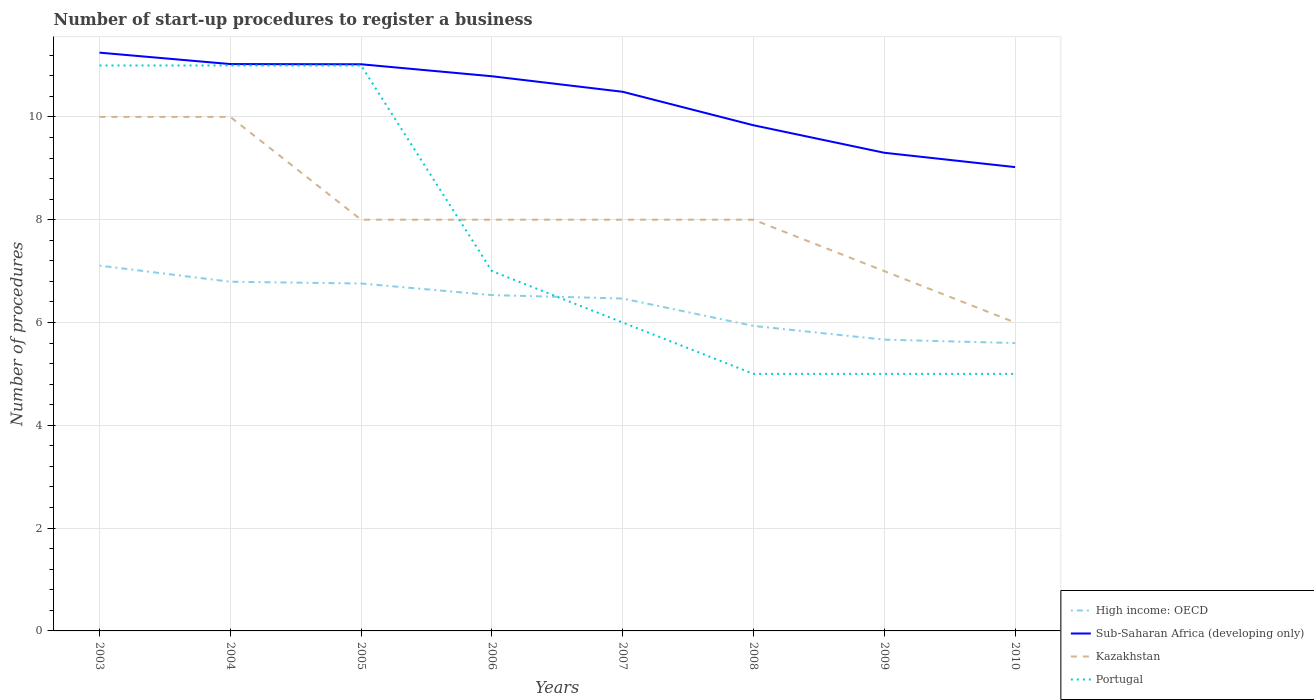Across all years, what is the maximum number of procedures required to register a business in Sub-Saharan Africa (developing only)?
Offer a very short reply. 9.02. In which year was the number of procedures required to register a business in Kazakhstan maximum?
Ensure brevity in your answer.  2010. What is the total number of procedures required to register a business in High income: OECD in the graph?
Your answer should be compact. 0.07. What is the difference between the highest and the lowest number of procedures required to register a business in Sub-Saharan Africa (developing only)?
Ensure brevity in your answer.  5. How many lines are there?
Give a very brief answer. 4. What is the difference between two consecutive major ticks on the Y-axis?
Ensure brevity in your answer.  2. Does the graph contain grids?
Offer a terse response. Yes. What is the title of the graph?
Provide a succinct answer. Number of start-up procedures to register a business. Does "Equatorial Guinea" appear as one of the legend labels in the graph?
Give a very brief answer. No. What is the label or title of the X-axis?
Offer a terse response. Years. What is the label or title of the Y-axis?
Your answer should be compact. Number of procedures. What is the Number of procedures in High income: OECD in 2003?
Give a very brief answer. 7.11. What is the Number of procedures of Sub-Saharan Africa (developing only) in 2003?
Your answer should be compact. 11.25. What is the Number of procedures in High income: OECD in 2004?
Offer a very short reply. 6.79. What is the Number of procedures in Sub-Saharan Africa (developing only) in 2004?
Offer a terse response. 11.03. What is the Number of procedures in High income: OECD in 2005?
Offer a terse response. 6.76. What is the Number of procedures of Sub-Saharan Africa (developing only) in 2005?
Your response must be concise. 11.02. What is the Number of procedures in Kazakhstan in 2005?
Give a very brief answer. 8. What is the Number of procedures of Portugal in 2005?
Offer a very short reply. 11. What is the Number of procedures of High income: OECD in 2006?
Ensure brevity in your answer.  6.53. What is the Number of procedures of Sub-Saharan Africa (developing only) in 2006?
Provide a succinct answer. 10.79. What is the Number of procedures in High income: OECD in 2007?
Your answer should be very brief. 6.47. What is the Number of procedures of Sub-Saharan Africa (developing only) in 2007?
Your answer should be very brief. 10.49. What is the Number of procedures of Kazakhstan in 2007?
Ensure brevity in your answer.  8. What is the Number of procedures of High income: OECD in 2008?
Offer a terse response. 5.93. What is the Number of procedures of Sub-Saharan Africa (developing only) in 2008?
Your answer should be very brief. 9.84. What is the Number of procedures in Kazakhstan in 2008?
Your answer should be very brief. 8. What is the Number of procedures of Portugal in 2008?
Offer a terse response. 5. What is the Number of procedures of High income: OECD in 2009?
Provide a succinct answer. 5.67. What is the Number of procedures of Sub-Saharan Africa (developing only) in 2009?
Offer a terse response. 9.3. What is the Number of procedures of Kazakhstan in 2009?
Offer a very short reply. 7. What is the Number of procedures of Sub-Saharan Africa (developing only) in 2010?
Make the answer very short. 9.02. What is the Number of procedures in Kazakhstan in 2010?
Offer a terse response. 6. Across all years, what is the maximum Number of procedures of High income: OECD?
Make the answer very short. 7.11. Across all years, what is the maximum Number of procedures of Sub-Saharan Africa (developing only)?
Offer a very short reply. 11.25. Across all years, what is the minimum Number of procedures in High income: OECD?
Your answer should be compact. 5.6. Across all years, what is the minimum Number of procedures of Sub-Saharan Africa (developing only)?
Offer a very short reply. 9.02. Across all years, what is the minimum Number of procedures of Portugal?
Your answer should be very brief. 5. What is the total Number of procedures of High income: OECD in the graph?
Provide a short and direct response. 50.86. What is the total Number of procedures in Sub-Saharan Africa (developing only) in the graph?
Your response must be concise. 82.74. What is the total Number of procedures of Portugal in the graph?
Keep it short and to the point. 61. What is the difference between the Number of procedures in High income: OECD in 2003 and that in 2004?
Offer a terse response. 0.31. What is the difference between the Number of procedures in Sub-Saharan Africa (developing only) in 2003 and that in 2004?
Your answer should be compact. 0.22. What is the difference between the Number of procedures in High income: OECD in 2003 and that in 2005?
Ensure brevity in your answer.  0.35. What is the difference between the Number of procedures of Sub-Saharan Africa (developing only) in 2003 and that in 2005?
Your answer should be compact. 0.23. What is the difference between the Number of procedures in High income: OECD in 2003 and that in 2006?
Provide a succinct answer. 0.57. What is the difference between the Number of procedures in Sub-Saharan Africa (developing only) in 2003 and that in 2006?
Make the answer very short. 0.46. What is the difference between the Number of procedures in Kazakhstan in 2003 and that in 2006?
Your answer should be compact. 2. What is the difference between the Number of procedures of High income: OECD in 2003 and that in 2007?
Your answer should be compact. 0.64. What is the difference between the Number of procedures in Sub-Saharan Africa (developing only) in 2003 and that in 2007?
Your answer should be very brief. 0.76. What is the difference between the Number of procedures in Portugal in 2003 and that in 2007?
Your answer should be compact. 5. What is the difference between the Number of procedures in High income: OECD in 2003 and that in 2008?
Your answer should be very brief. 1.17. What is the difference between the Number of procedures in Sub-Saharan Africa (developing only) in 2003 and that in 2008?
Your answer should be very brief. 1.41. What is the difference between the Number of procedures of Portugal in 2003 and that in 2008?
Your answer should be compact. 6. What is the difference between the Number of procedures in High income: OECD in 2003 and that in 2009?
Provide a short and direct response. 1.44. What is the difference between the Number of procedures in Sub-Saharan Africa (developing only) in 2003 and that in 2009?
Give a very brief answer. 1.95. What is the difference between the Number of procedures of Portugal in 2003 and that in 2009?
Keep it short and to the point. 6. What is the difference between the Number of procedures of High income: OECD in 2003 and that in 2010?
Give a very brief answer. 1.51. What is the difference between the Number of procedures of Sub-Saharan Africa (developing only) in 2003 and that in 2010?
Give a very brief answer. 2.23. What is the difference between the Number of procedures of Kazakhstan in 2003 and that in 2010?
Offer a very short reply. 4. What is the difference between the Number of procedures in High income: OECD in 2004 and that in 2005?
Provide a succinct answer. 0.03. What is the difference between the Number of procedures of Sub-Saharan Africa (developing only) in 2004 and that in 2005?
Provide a short and direct response. 0. What is the difference between the Number of procedures in Kazakhstan in 2004 and that in 2005?
Offer a terse response. 2. What is the difference between the Number of procedures of High income: OECD in 2004 and that in 2006?
Make the answer very short. 0.26. What is the difference between the Number of procedures in Sub-Saharan Africa (developing only) in 2004 and that in 2006?
Offer a very short reply. 0.24. What is the difference between the Number of procedures of Portugal in 2004 and that in 2006?
Ensure brevity in your answer.  4. What is the difference between the Number of procedures of High income: OECD in 2004 and that in 2007?
Provide a succinct answer. 0.33. What is the difference between the Number of procedures of Sub-Saharan Africa (developing only) in 2004 and that in 2007?
Your answer should be compact. 0.54. What is the difference between the Number of procedures of Kazakhstan in 2004 and that in 2007?
Your answer should be very brief. 2. What is the difference between the Number of procedures in Portugal in 2004 and that in 2007?
Ensure brevity in your answer.  5. What is the difference between the Number of procedures in High income: OECD in 2004 and that in 2008?
Give a very brief answer. 0.86. What is the difference between the Number of procedures of Sub-Saharan Africa (developing only) in 2004 and that in 2008?
Provide a succinct answer. 1.19. What is the difference between the Number of procedures of High income: OECD in 2004 and that in 2009?
Keep it short and to the point. 1.13. What is the difference between the Number of procedures in Sub-Saharan Africa (developing only) in 2004 and that in 2009?
Offer a very short reply. 1.73. What is the difference between the Number of procedures in Kazakhstan in 2004 and that in 2009?
Provide a short and direct response. 3. What is the difference between the Number of procedures in High income: OECD in 2004 and that in 2010?
Ensure brevity in your answer.  1.19. What is the difference between the Number of procedures in Sub-Saharan Africa (developing only) in 2004 and that in 2010?
Give a very brief answer. 2. What is the difference between the Number of procedures of Kazakhstan in 2004 and that in 2010?
Offer a terse response. 4. What is the difference between the Number of procedures of Portugal in 2004 and that in 2010?
Give a very brief answer. 6. What is the difference between the Number of procedures in High income: OECD in 2005 and that in 2006?
Your response must be concise. 0.23. What is the difference between the Number of procedures in Sub-Saharan Africa (developing only) in 2005 and that in 2006?
Make the answer very short. 0.23. What is the difference between the Number of procedures of Kazakhstan in 2005 and that in 2006?
Ensure brevity in your answer.  0. What is the difference between the Number of procedures in High income: OECD in 2005 and that in 2007?
Offer a terse response. 0.29. What is the difference between the Number of procedures in Sub-Saharan Africa (developing only) in 2005 and that in 2007?
Provide a succinct answer. 0.54. What is the difference between the Number of procedures of Kazakhstan in 2005 and that in 2007?
Your answer should be very brief. 0. What is the difference between the Number of procedures of High income: OECD in 2005 and that in 2008?
Provide a succinct answer. 0.83. What is the difference between the Number of procedures in Sub-Saharan Africa (developing only) in 2005 and that in 2008?
Make the answer very short. 1.19. What is the difference between the Number of procedures in Kazakhstan in 2005 and that in 2008?
Your answer should be compact. 0. What is the difference between the Number of procedures of Portugal in 2005 and that in 2008?
Keep it short and to the point. 6. What is the difference between the Number of procedures in High income: OECD in 2005 and that in 2009?
Offer a terse response. 1.09. What is the difference between the Number of procedures in Sub-Saharan Africa (developing only) in 2005 and that in 2009?
Offer a terse response. 1.72. What is the difference between the Number of procedures in Kazakhstan in 2005 and that in 2009?
Your answer should be compact. 1. What is the difference between the Number of procedures of High income: OECD in 2005 and that in 2010?
Ensure brevity in your answer.  1.16. What is the difference between the Number of procedures of Sub-Saharan Africa (developing only) in 2005 and that in 2010?
Your answer should be very brief. 2. What is the difference between the Number of procedures in Kazakhstan in 2005 and that in 2010?
Offer a terse response. 2. What is the difference between the Number of procedures in High income: OECD in 2006 and that in 2007?
Your answer should be very brief. 0.07. What is the difference between the Number of procedures of Sub-Saharan Africa (developing only) in 2006 and that in 2007?
Give a very brief answer. 0.3. What is the difference between the Number of procedures of Sub-Saharan Africa (developing only) in 2006 and that in 2008?
Offer a very short reply. 0.95. What is the difference between the Number of procedures of Kazakhstan in 2006 and that in 2008?
Offer a terse response. 0. What is the difference between the Number of procedures in High income: OECD in 2006 and that in 2009?
Offer a very short reply. 0.87. What is the difference between the Number of procedures of Sub-Saharan Africa (developing only) in 2006 and that in 2009?
Your response must be concise. 1.49. What is the difference between the Number of procedures of Portugal in 2006 and that in 2009?
Your response must be concise. 2. What is the difference between the Number of procedures in Sub-Saharan Africa (developing only) in 2006 and that in 2010?
Ensure brevity in your answer.  1.77. What is the difference between the Number of procedures of Portugal in 2006 and that in 2010?
Offer a terse response. 2. What is the difference between the Number of procedures in High income: OECD in 2007 and that in 2008?
Make the answer very short. 0.53. What is the difference between the Number of procedures in Sub-Saharan Africa (developing only) in 2007 and that in 2008?
Your answer should be very brief. 0.65. What is the difference between the Number of procedures of Kazakhstan in 2007 and that in 2008?
Provide a succinct answer. 0. What is the difference between the Number of procedures in Sub-Saharan Africa (developing only) in 2007 and that in 2009?
Your answer should be very brief. 1.19. What is the difference between the Number of procedures of Kazakhstan in 2007 and that in 2009?
Make the answer very short. 1. What is the difference between the Number of procedures of Portugal in 2007 and that in 2009?
Your response must be concise. 1. What is the difference between the Number of procedures in High income: OECD in 2007 and that in 2010?
Keep it short and to the point. 0.87. What is the difference between the Number of procedures of Sub-Saharan Africa (developing only) in 2007 and that in 2010?
Your answer should be compact. 1.47. What is the difference between the Number of procedures in Kazakhstan in 2007 and that in 2010?
Make the answer very short. 2. What is the difference between the Number of procedures of Portugal in 2007 and that in 2010?
Offer a terse response. 1. What is the difference between the Number of procedures of High income: OECD in 2008 and that in 2009?
Offer a very short reply. 0.27. What is the difference between the Number of procedures of Sub-Saharan Africa (developing only) in 2008 and that in 2009?
Make the answer very short. 0.53. What is the difference between the Number of procedures of High income: OECD in 2008 and that in 2010?
Provide a short and direct response. 0.33. What is the difference between the Number of procedures in Sub-Saharan Africa (developing only) in 2008 and that in 2010?
Provide a succinct answer. 0.81. What is the difference between the Number of procedures in High income: OECD in 2009 and that in 2010?
Offer a terse response. 0.07. What is the difference between the Number of procedures in Sub-Saharan Africa (developing only) in 2009 and that in 2010?
Your answer should be compact. 0.28. What is the difference between the Number of procedures of Kazakhstan in 2009 and that in 2010?
Offer a very short reply. 1. What is the difference between the Number of procedures of High income: OECD in 2003 and the Number of procedures of Sub-Saharan Africa (developing only) in 2004?
Ensure brevity in your answer.  -3.92. What is the difference between the Number of procedures of High income: OECD in 2003 and the Number of procedures of Kazakhstan in 2004?
Keep it short and to the point. -2.89. What is the difference between the Number of procedures in High income: OECD in 2003 and the Number of procedures in Portugal in 2004?
Keep it short and to the point. -3.89. What is the difference between the Number of procedures in Sub-Saharan Africa (developing only) in 2003 and the Number of procedures in Kazakhstan in 2004?
Make the answer very short. 1.25. What is the difference between the Number of procedures in Kazakhstan in 2003 and the Number of procedures in Portugal in 2004?
Provide a succinct answer. -1. What is the difference between the Number of procedures of High income: OECD in 2003 and the Number of procedures of Sub-Saharan Africa (developing only) in 2005?
Your response must be concise. -3.92. What is the difference between the Number of procedures in High income: OECD in 2003 and the Number of procedures in Kazakhstan in 2005?
Provide a succinct answer. -0.89. What is the difference between the Number of procedures of High income: OECD in 2003 and the Number of procedures of Portugal in 2005?
Offer a terse response. -3.89. What is the difference between the Number of procedures in Sub-Saharan Africa (developing only) in 2003 and the Number of procedures in Kazakhstan in 2005?
Your answer should be compact. 3.25. What is the difference between the Number of procedures in High income: OECD in 2003 and the Number of procedures in Sub-Saharan Africa (developing only) in 2006?
Offer a very short reply. -3.68. What is the difference between the Number of procedures in High income: OECD in 2003 and the Number of procedures in Kazakhstan in 2006?
Your answer should be very brief. -0.89. What is the difference between the Number of procedures in High income: OECD in 2003 and the Number of procedures in Portugal in 2006?
Offer a terse response. 0.11. What is the difference between the Number of procedures in Sub-Saharan Africa (developing only) in 2003 and the Number of procedures in Kazakhstan in 2006?
Provide a short and direct response. 3.25. What is the difference between the Number of procedures of Sub-Saharan Africa (developing only) in 2003 and the Number of procedures of Portugal in 2006?
Provide a short and direct response. 4.25. What is the difference between the Number of procedures in High income: OECD in 2003 and the Number of procedures in Sub-Saharan Africa (developing only) in 2007?
Provide a succinct answer. -3.38. What is the difference between the Number of procedures of High income: OECD in 2003 and the Number of procedures of Kazakhstan in 2007?
Your answer should be compact. -0.89. What is the difference between the Number of procedures in High income: OECD in 2003 and the Number of procedures in Portugal in 2007?
Ensure brevity in your answer.  1.11. What is the difference between the Number of procedures of Sub-Saharan Africa (developing only) in 2003 and the Number of procedures of Kazakhstan in 2007?
Your answer should be very brief. 3.25. What is the difference between the Number of procedures of Sub-Saharan Africa (developing only) in 2003 and the Number of procedures of Portugal in 2007?
Give a very brief answer. 5.25. What is the difference between the Number of procedures in High income: OECD in 2003 and the Number of procedures in Sub-Saharan Africa (developing only) in 2008?
Give a very brief answer. -2.73. What is the difference between the Number of procedures of High income: OECD in 2003 and the Number of procedures of Kazakhstan in 2008?
Your response must be concise. -0.89. What is the difference between the Number of procedures in High income: OECD in 2003 and the Number of procedures in Portugal in 2008?
Keep it short and to the point. 2.11. What is the difference between the Number of procedures in Sub-Saharan Africa (developing only) in 2003 and the Number of procedures in Kazakhstan in 2008?
Keep it short and to the point. 3.25. What is the difference between the Number of procedures of Sub-Saharan Africa (developing only) in 2003 and the Number of procedures of Portugal in 2008?
Give a very brief answer. 6.25. What is the difference between the Number of procedures of High income: OECD in 2003 and the Number of procedures of Sub-Saharan Africa (developing only) in 2009?
Offer a very short reply. -2.2. What is the difference between the Number of procedures of High income: OECD in 2003 and the Number of procedures of Kazakhstan in 2009?
Provide a short and direct response. 0.11. What is the difference between the Number of procedures of High income: OECD in 2003 and the Number of procedures of Portugal in 2009?
Provide a short and direct response. 2.11. What is the difference between the Number of procedures in Sub-Saharan Africa (developing only) in 2003 and the Number of procedures in Kazakhstan in 2009?
Ensure brevity in your answer.  4.25. What is the difference between the Number of procedures in Sub-Saharan Africa (developing only) in 2003 and the Number of procedures in Portugal in 2009?
Offer a terse response. 6.25. What is the difference between the Number of procedures of High income: OECD in 2003 and the Number of procedures of Sub-Saharan Africa (developing only) in 2010?
Your response must be concise. -1.92. What is the difference between the Number of procedures of High income: OECD in 2003 and the Number of procedures of Kazakhstan in 2010?
Your answer should be very brief. 1.11. What is the difference between the Number of procedures of High income: OECD in 2003 and the Number of procedures of Portugal in 2010?
Keep it short and to the point. 2.11. What is the difference between the Number of procedures in Sub-Saharan Africa (developing only) in 2003 and the Number of procedures in Kazakhstan in 2010?
Your response must be concise. 5.25. What is the difference between the Number of procedures in Sub-Saharan Africa (developing only) in 2003 and the Number of procedures in Portugal in 2010?
Your answer should be compact. 6.25. What is the difference between the Number of procedures of Kazakhstan in 2003 and the Number of procedures of Portugal in 2010?
Your answer should be compact. 5. What is the difference between the Number of procedures in High income: OECD in 2004 and the Number of procedures in Sub-Saharan Africa (developing only) in 2005?
Provide a succinct answer. -4.23. What is the difference between the Number of procedures in High income: OECD in 2004 and the Number of procedures in Kazakhstan in 2005?
Give a very brief answer. -1.21. What is the difference between the Number of procedures in High income: OECD in 2004 and the Number of procedures in Portugal in 2005?
Ensure brevity in your answer.  -4.21. What is the difference between the Number of procedures of Sub-Saharan Africa (developing only) in 2004 and the Number of procedures of Kazakhstan in 2005?
Offer a terse response. 3.03. What is the difference between the Number of procedures of Sub-Saharan Africa (developing only) in 2004 and the Number of procedures of Portugal in 2005?
Keep it short and to the point. 0.03. What is the difference between the Number of procedures of High income: OECD in 2004 and the Number of procedures of Sub-Saharan Africa (developing only) in 2006?
Give a very brief answer. -4. What is the difference between the Number of procedures of High income: OECD in 2004 and the Number of procedures of Kazakhstan in 2006?
Ensure brevity in your answer.  -1.21. What is the difference between the Number of procedures of High income: OECD in 2004 and the Number of procedures of Portugal in 2006?
Give a very brief answer. -0.21. What is the difference between the Number of procedures in Sub-Saharan Africa (developing only) in 2004 and the Number of procedures in Kazakhstan in 2006?
Your answer should be compact. 3.03. What is the difference between the Number of procedures in Sub-Saharan Africa (developing only) in 2004 and the Number of procedures in Portugal in 2006?
Give a very brief answer. 4.03. What is the difference between the Number of procedures in Kazakhstan in 2004 and the Number of procedures in Portugal in 2006?
Provide a short and direct response. 3. What is the difference between the Number of procedures in High income: OECD in 2004 and the Number of procedures in Sub-Saharan Africa (developing only) in 2007?
Your answer should be very brief. -3.7. What is the difference between the Number of procedures in High income: OECD in 2004 and the Number of procedures in Kazakhstan in 2007?
Provide a succinct answer. -1.21. What is the difference between the Number of procedures of High income: OECD in 2004 and the Number of procedures of Portugal in 2007?
Provide a short and direct response. 0.79. What is the difference between the Number of procedures of Sub-Saharan Africa (developing only) in 2004 and the Number of procedures of Kazakhstan in 2007?
Give a very brief answer. 3.03. What is the difference between the Number of procedures of Sub-Saharan Africa (developing only) in 2004 and the Number of procedures of Portugal in 2007?
Ensure brevity in your answer.  5.03. What is the difference between the Number of procedures of Kazakhstan in 2004 and the Number of procedures of Portugal in 2007?
Your answer should be very brief. 4. What is the difference between the Number of procedures of High income: OECD in 2004 and the Number of procedures of Sub-Saharan Africa (developing only) in 2008?
Ensure brevity in your answer.  -3.04. What is the difference between the Number of procedures in High income: OECD in 2004 and the Number of procedures in Kazakhstan in 2008?
Your answer should be very brief. -1.21. What is the difference between the Number of procedures of High income: OECD in 2004 and the Number of procedures of Portugal in 2008?
Give a very brief answer. 1.79. What is the difference between the Number of procedures of Sub-Saharan Africa (developing only) in 2004 and the Number of procedures of Kazakhstan in 2008?
Provide a short and direct response. 3.03. What is the difference between the Number of procedures in Sub-Saharan Africa (developing only) in 2004 and the Number of procedures in Portugal in 2008?
Offer a very short reply. 6.03. What is the difference between the Number of procedures in Kazakhstan in 2004 and the Number of procedures in Portugal in 2008?
Give a very brief answer. 5. What is the difference between the Number of procedures in High income: OECD in 2004 and the Number of procedures in Sub-Saharan Africa (developing only) in 2009?
Give a very brief answer. -2.51. What is the difference between the Number of procedures of High income: OECD in 2004 and the Number of procedures of Kazakhstan in 2009?
Provide a succinct answer. -0.21. What is the difference between the Number of procedures in High income: OECD in 2004 and the Number of procedures in Portugal in 2009?
Provide a succinct answer. 1.79. What is the difference between the Number of procedures in Sub-Saharan Africa (developing only) in 2004 and the Number of procedures in Kazakhstan in 2009?
Ensure brevity in your answer.  4.03. What is the difference between the Number of procedures of Sub-Saharan Africa (developing only) in 2004 and the Number of procedures of Portugal in 2009?
Give a very brief answer. 6.03. What is the difference between the Number of procedures of Kazakhstan in 2004 and the Number of procedures of Portugal in 2009?
Your answer should be very brief. 5. What is the difference between the Number of procedures of High income: OECD in 2004 and the Number of procedures of Sub-Saharan Africa (developing only) in 2010?
Offer a very short reply. -2.23. What is the difference between the Number of procedures in High income: OECD in 2004 and the Number of procedures in Kazakhstan in 2010?
Your answer should be very brief. 0.79. What is the difference between the Number of procedures in High income: OECD in 2004 and the Number of procedures in Portugal in 2010?
Keep it short and to the point. 1.79. What is the difference between the Number of procedures of Sub-Saharan Africa (developing only) in 2004 and the Number of procedures of Kazakhstan in 2010?
Offer a very short reply. 5.03. What is the difference between the Number of procedures in Sub-Saharan Africa (developing only) in 2004 and the Number of procedures in Portugal in 2010?
Provide a short and direct response. 6.03. What is the difference between the Number of procedures of High income: OECD in 2005 and the Number of procedures of Sub-Saharan Africa (developing only) in 2006?
Keep it short and to the point. -4.03. What is the difference between the Number of procedures in High income: OECD in 2005 and the Number of procedures in Kazakhstan in 2006?
Offer a terse response. -1.24. What is the difference between the Number of procedures in High income: OECD in 2005 and the Number of procedures in Portugal in 2006?
Provide a succinct answer. -0.24. What is the difference between the Number of procedures in Sub-Saharan Africa (developing only) in 2005 and the Number of procedures in Kazakhstan in 2006?
Provide a short and direct response. 3.02. What is the difference between the Number of procedures in Sub-Saharan Africa (developing only) in 2005 and the Number of procedures in Portugal in 2006?
Keep it short and to the point. 4.02. What is the difference between the Number of procedures of High income: OECD in 2005 and the Number of procedures of Sub-Saharan Africa (developing only) in 2007?
Offer a terse response. -3.73. What is the difference between the Number of procedures in High income: OECD in 2005 and the Number of procedures in Kazakhstan in 2007?
Offer a very short reply. -1.24. What is the difference between the Number of procedures of High income: OECD in 2005 and the Number of procedures of Portugal in 2007?
Keep it short and to the point. 0.76. What is the difference between the Number of procedures of Sub-Saharan Africa (developing only) in 2005 and the Number of procedures of Kazakhstan in 2007?
Offer a very short reply. 3.02. What is the difference between the Number of procedures of Sub-Saharan Africa (developing only) in 2005 and the Number of procedures of Portugal in 2007?
Ensure brevity in your answer.  5.02. What is the difference between the Number of procedures in High income: OECD in 2005 and the Number of procedures in Sub-Saharan Africa (developing only) in 2008?
Your answer should be compact. -3.08. What is the difference between the Number of procedures in High income: OECD in 2005 and the Number of procedures in Kazakhstan in 2008?
Provide a succinct answer. -1.24. What is the difference between the Number of procedures of High income: OECD in 2005 and the Number of procedures of Portugal in 2008?
Offer a very short reply. 1.76. What is the difference between the Number of procedures in Sub-Saharan Africa (developing only) in 2005 and the Number of procedures in Kazakhstan in 2008?
Offer a terse response. 3.02. What is the difference between the Number of procedures in Sub-Saharan Africa (developing only) in 2005 and the Number of procedures in Portugal in 2008?
Make the answer very short. 6.02. What is the difference between the Number of procedures in Kazakhstan in 2005 and the Number of procedures in Portugal in 2008?
Provide a short and direct response. 3. What is the difference between the Number of procedures in High income: OECD in 2005 and the Number of procedures in Sub-Saharan Africa (developing only) in 2009?
Keep it short and to the point. -2.54. What is the difference between the Number of procedures of High income: OECD in 2005 and the Number of procedures of Kazakhstan in 2009?
Offer a terse response. -0.24. What is the difference between the Number of procedures of High income: OECD in 2005 and the Number of procedures of Portugal in 2009?
Your answer should be very brief. 1.76. What is the difference between the Number of procedures in Sub-Saharan Africa (developing only) in 2005 and the Number of procedures in Kazakhstan in 2009?
Offer a terse response. 4.02. What is the difference between the Number of procedures of Sub-Saharan Africa (developing only) in 2005 and the Number of procedures of Portugal in 2009?
Your response must be concise. 6.02. What is the difference between the Number of procedures in High income: OECD in 2005 and the Number of procedures in Sub-Saharan Africa (developing only) in 2010?
Your response must be concise. -2.26. What is the difference between the Number of procedures in High income: OECD in 2005 and the Number of procedures in Kazakhstan in 2010?
Keep it short and to the point. 0.76. What is the difference between the Number of procedures of High income: OECD in 2005 and the Number of procedures of Portugal in 2010?
Your answer should be compact. 1.76. What is the difference between the Number of procedures of Sub-Saharan Africa (developing only) in 2005 and the Number of procedures of Kazakhstan in 2010?
Offer a terse response. 5.02. What is the difference between the Number of procedures in Sub-Saharan Africa (developing only) in 2005 and the Number of procedures in Portugal in 2010?
Give a very brief answer. 6.02. What is the difference between the Number of procedures of High income: OECD in 2006 and the Number of procedures of Sub-Saharan Africa (developing only) in 2007?
Your answer should be compact. -3.96. What is the difference between the Number of procedures in High income: OECD in 2006 and the Number of procedures in Kazakhstan in 2007?
Your response must be concise. -1.47. What is the difference between the Number of procedures of High income: OECD in 2006 and the Number of procedures of Portugal in 2007?
Provide a short and direct response. 0.53. What is the difference between the Number of procedures of Sub-Saharan Africa (developing only) in 2006 and the Number of procedures of Kazakhstan in 2007?
Your answer should be very brief. 2.79. What is the difference between the Number of procedures in Sub-Saharan Africa (developing only) in 2006 and the Number of procedures in Portugal in 2007?
Give a very brief answer. 4.79. What is the difference between the Number of procedures in High income: OECD in 2006 and the Number of procedures in Sub-Saharan Africa (developing only) in 2008?
Offer a terse response. -3.3. What is the difference between the Number of procedures of High income: OECD in 2006 and the Number of procedures of Kazakhstan in 2008?
Your answer should be compact. -1.47. What is the difference between the Number of procedures in High income: OECD in 2006 and the Number of procedures in Portugal in 2008?
Offer a terse response. 1.53. What is the difference between the Number of procedures in Sub-Saharan Africa (developing only) in 2006 and the Number of procedures in Kazakhstan in 2008?
Keep it short and to the point. 2.79. What is the difference between the Number of procedures of Sub-Saharan Africa (developing only) in 2006 and the Number of procedures of Portugal in 2008?
Your response must be concise. 5.79. What is the difference between the Number of procedures in High income: OECD in 2006 and the Number of procedures in Sub-Saharan Africa (developing only) in 2009?
Offer a terse response. -2.77. What is the difference between the Number of procedures of High income: OECD in 2006 and the Number of procedures of Kazakhstan in 2009?
Your answer should be very brief. -0.47. What is the difference between the Number of procedures of High income: OECD in 2006 and the Number of procedures of Portugal in 2009?
Your answer should be compact. 1.53. What is the difference between the Number of procedures of Sub-Saharan Africa (developing only) in 2006 and the Number of procedures of Kazakhstan in 2009?
Provide a short and direct response. 3.79. What is the difference between the Number of procedures in Sub-Saharan Africa (developing only) in 2006 and the Number of procedures in Portugal in 2009?
Give a very brief answer. 5.79. What is the difference between the Number of procedures in Kazakhstan in 2006 and the Number of procedures in Portugal in 2009?
Offer a very short reply. 3. What is the difference between the Number of procedures of High income: OECD in 2006 and the Number of procedures of Sub-Saharan Africa (developing only) in 2010?
Keep it short and to the point. -2.49. What is the difference between the Number of procedures of High income: OECD in 2006 and the Number of procedures of Kazakhstan in 2010?
Your response must be concise. 0.53. What is the difference between the Number of procedures of High income: OECD in 2006 and the Number of procedures of Portugal in 2010?
Your response must be concise. 1.53. What is the difference between the Number of procedures of Sub-Saharan Africa (developing only) in 2006 and the Number of procedures of Kazakhstan in 2010?
Your answer should be very brief. 4.79. What is the difference between the Number of procedures in Sub-Saharan Africa (developing only) in 2006 and the Number of procedures in Portugal in 2010?
Offer a terse response. 5.79. What is the difference between the Number of procedures in High income: OECD in 2007 and the Number of procedures in Sub-Saharan Africa (developing only) in 2008?
Ensure brevity in your answer.  -3.37. What is the difference between the Number of procedures in High income: OECD in 2007 and the Number of procedures in Kazakhstan in 2008?
Make the answer very short. -1.53. What is the difference between the Number of procedures of High income: OECD in 2007 and the Number of procedures of Portugal in 2008?
Provide a short and direct response. 1.47. What is the difference between the Number of procedures of Sub-Saharan Africa (developing only) in 2007 and the Number of procedures of Kazakhstan in 2008?
Make the answer very short. 2.49. What is the difference between the Number of procedures of Sub-Saharan Africa (developing only) in 2007 and the Number of procedures of Portugal in 2008?
Offer a terse response. 5.49. What is the difference between the Number of procedures in Kazakhstan in 2007 and the Number of procedures in Portugal in 2008?
Your answer should be compact. 3. What is the difference between the Number of procedures in High income: OECD in 2007 and the Number of procedures in Sub-Saharan Africa (developing only) in 2009?
Offer a terse response. -2.84. What is the difference between the Number of procedures of High income: OECD in 2007 and the Number of procedures of Kazakhstan in 2009?
Your answer should be compact. -0.53. What is the difference between the Number of procedures in High income: OECD in 2007 and the Number of procedures in Portugal in 2009?
Keep it short and to the point. 1.47. What is the difference between the Number of procedures in Sub-Saharan Africa (developing only) in 2007 and the Number of procedures in Kazakhstan in 2009?
Provide a succinct answer. 3.49. What is the difference between the Number of procedures in Sub-Saharan Africa (developing only) in 2007 and the Number of procedures in Portugal in 2009?
Your answer should be very brief. 5.49. What is the difference between the Number of procedures of Kazakhstan in 2007 and the Number of procedures of Portugal in 2009?
Offer a terse response. 3. What is the difference between the Number of procedures in High income: OECD in 2007 and the Number of procedures in Sub-Saharan Africa (developing only) in 2010?
Provide a succinct answer. -2.56. What is the difference between the Number of procedures in High income: OECD in 2007 and the Number of procedures in Kazakhstan in 2010?
Provide a succinct answer. 0.47. What is the difference between the Number of procedures in High income: OECD in 2007 and the Number of procedures in Portugal in 2010?
Make the answer very short. 1.47. What is the difference between the Number of procedures in Sub-Saharan Africa (developing only) in 2007 and the Number of procedures in Kazakhstan in 2010?
Make the answer very short. 4.49. What is the difference between the Number of procedures in Sub-Saharan Africa (developing only) in 2007 and the Number of procedures in Portugal in 2010?
Provide a succinct answer. 5.49. What is the difference between the Number of procedures of Kazakhstan in 2007 and the Number of procedures of Portugal in 2010?
Make the answer very short. 3. What is the difference between the Number of procedures of High income: OECD in 2008 and the Number of procedures of Sub-Saharan Africa (developing only) in 2009?
Keep it short and to the point. -3.37. What is the difference between the Number of procedures in High income: OECD in 2008 and the Number of procedures in Kazakhstan in 2009?
Your answer should be compact. -1.07. What is the difference between the Number of procedures in Sub-Saharan Africa (developing only) in 2008 and the Number of procedures in Kazakhstan in 2009?
Offer a terse response. 2.84. What is the difference between the Number of procedures of Sub-Saharan Africa (developing only) in 2008 and the Number of procedures of Portugal in 2009?
Offer a terse response. 4.84. What is the difference between the Number of procedures in Kazakhstan in 2008 and the Number of procedures in Portugal in 2009?
Offer a very short reply. 3. What is the difference between the Number of procedures of High income: OECD in 2008 and the Number of procedures of Sub-Saharan Africa (developing only) in 2010?
Offer a very short reply. -3.09. What is the difference between the Number of procedures of High income: OECD in 2008 and the Number of procedures of Kazakhstan in 2010?
Offer a very short reply. -0.07. What is the difference between the Number of procedures in Sub-Saharan Africa (developing only) in 2008 and the Number of procedures in Kazakhstan in 2010?
Provide a short and direct response. 3.84. What is the difference between the Number of procedures of Sub-Saharan Africa (developing only) in 2008 and the Number of procedures of Portugal in 2010?
Your answer should be compact. 4.84. What is the difference between the Number of procedures of Kazakhstan in 2008 and the Number of procedures of Portugal in 2010?
Keep it short and to the point. 3. What is the difference between the Number of procedures in High income: OECD in 2009 and the Number of procedures in Sub-Saharan Africa (developing only) in 2010?
Your answer should be compact. -3.36. What is the difference between the Number of procedures of High income: OECD in 2009 and the Number of procedures of Kazakhstan in 2010?
Give a very brief answer. -0.33. What is the difference between the Number of procedures of Sub-Saharan Africa (developing only) in 2009 and the Number of procedures of Kazakhstan in 2010?
Your answer should be compact. 3.3. What is the difference between the Number of procedures of Sub-Saharan Africa (developing only) in 2009 and the Number of procedures of Portugal in 2010?
Offer a terse response. 4.3. What is the difference between the Number of procedures of Kazakhstan in 2009 and the Number of procedures of Portugal in 2010?
Provide a succinct answer. 2. What is the average Number of procedures in High income: OECD per year?
Ensure brevity in your answer.  6.36. What is the average Number of procedures in Sub-Saharan Africa (developing only) per year?
Ensure brevity in your answer.  10.34. What is the average Number of procedures of Kazakhstan per year?
Your answer should be compact. 8.12. What is the average Number of procedures in Portugal per year?
Keep it short and to the point. 7.62. In the year 2003, what is the difference between the Number of procedures in High income: OECD and Number of procedures in Sub-Saharan Africa (developing only)?
Your answer should be very brief. -4.14. In the year 2003, what is the difference between the Number of procedures of High income: OECD and Number of procedures of Kazakhstan?
Your answer should be very brief. -2.89. In the year 2003, what is the difference between the Number of procedures of High income: OECD and Number of procedures of Portugal?
Your answer should be very brief. -3.89. In the year 2003, what is the difference between the Number of procedures of Sub-Saharan Africa (developing only) and Number of procedures of Portugal?
Provide a short and direct response. 0.25. In the year 2004, what is the difference between the Number of procedures in High income: OECD and Number of procedures in Sub-Saharan Africa (developing only)?
Provide a succinct answer. -4.23. In the year 2004, what is the difference between the Number of procedures of High income: OECD and Number of procedures of Kazakhstan?
Offer a very short reply. -3.21. In the year 2004, what is the difference between the Number of procedures in High income: OECD and Number of procedures in Portugal?
Offer a very short reply. -4.21. In the year 2004, what is the difference between the Number of procedures in Sub-Saharan Africa (developing only) and Number of procedures in Kazakhstan?
Provide a short and direct response. 1.03. In the year 2004, what is the difference between the Number of procedures of Sub-Saharan Africa (developing only) and Number of procedures of Portugal?
Provide a succinct answer. 0.03. In the year 2005, what is the difference between the Number of procedures of High income: OECD and Number of procedures of Sub-Saharan Africa (developing only)?
Provide a succinct answer. -4.27. In the year 2005, what is the difference between the Number of procedures in High income: OECD and Number of procedures in Kazakhstan?
Offer a very short reply. -1.24. In the year 2005, what is the difference between the Number of procedures in High income: OECD and Number of procedures in Portugal?
Ensure brevity in your answer.  -4.24. In the year 2005, what is the difference between the Number of procedures in Sub-Saharan Africa (developing only) and Number of procedures in Kazakhstan?
Provide a short and direct response. 3.02. In the year 2005, what is the difference between the Number of procedures in Sub-Saharan Africa (developing only) and Number of procedures in Portugal?
Provide a short and direct response. 0.02. In the year 2005, what is the difference between the Number of procedures in Kazakhstan and Number of procedures in Portugal?
Provide a short and direct response. -3. In the year 2006, what is the difference between the Number of procedures in High income: OECD and Number of procedures in Sub-Saharan Africa (developing only)?
Offer a terse response. -4.26. In the year 2006, what is the difference between the Number of procedures of High income: OECD and Number of procedures of Kazakhstan?
Offer a terse response. -1.47. In the year 2006, what is the difference between the Number of procedures of High income: OECD and Number of procedures of Portugal?
Give a very brief answer. -0.47. In the year 2006, what is the difference between the Number of procedures of Sub-Saharan Africa (developing only) and Number of procedures of Kazakhstan?
Your response must be concise. 2.79. In the year 2006, what is the difference between the Number of procedures in Sub-Saharan Africa (developing only) and Number of procedures in Portugal?
Provide a succinct answer. 3.79. In the year 2007, what is the difference between the Number of procedures of High income: OECD and Number of procedures of Sub-Saharan Africa (developing only)?
Keep it short and to the point. -4.02. In the year 2007, what is the difference between the Number of procedures in High income: OECD and Number of procedures in Kazakhstan?
Ensure brevity in your answer.  -1.53. In the year 2007, what is the difference between the Number of procedures of High income: OECD and Number of procedures of Portugal?
Keep it short and to the point. 0.47. In the year 2007, what is the difference between the Number of procedures in Sub-Saharan Africa (developing only) and Number of procedures in Kazakhstan?
Provide a short and direct response. 2.49. In the year 2007, what is the difference between the Number of procedures in Sub-Saharan Africa (developing only) and Number of procedures in Portugal?
Your answer should be compact. 4.49. In the year 2008, what is the difference between the Number of procedures in High income: OECD and Number of procedures in Sub-Saharan Africa (developing only)?
Provide a short and direct response. -3.9. In the year 2008, what is the difference between the Number of procedures of High income: OECD and Number of procedures of Kazakhstan?
Provide a short and direct response. -2.07. In the year 2008, what is the difference between the Number of procedures of Sub-Saharan Africa (developing only) and Number of procedures of Kazakhstan?
Your answer should be compact. 1.84. In the year 2008, what is the difference between the Number of procedures of Sub-Saharan Africa (developing only) and Number of procedures of Portugal?
Ensure brevity in your answer.  4.84. In the year 2008, what is the difference between the Number of procedures of Kazakhstan and Number of procedures of Portugal?
Offer a very short reply. 3. In the year 2009, what is the difference between the Number of procedures of High income: OECD and Number of procedures of Sub-Saharan Africa (developing only)?
Provide a short and direct response. -3.64. In the year 2009, what is the difference between the Number of procedures of High income: OECD and Number of procedures of Kazakhstan?
Your answer should be compact. -1.33. In the year 2009, what is the difference between the Number of procedures in Sub-Saharan Africa (developing only) and Number of procedures in Kazakhstan?
Make the answer very short. 2.3. In the year 2009, what is the difference between the Number of procedures of Sub-Saharan Africa (developing only) and Number of procedures of Portugal?
Keep it short and to the point. 4.3. In the year 2010, what is the difference between the Number of procedures of High income: OECD and Number of procedures of Sub-Saharan Africa (developing only)?
Ensure brevity in your answer.  -3.42. In the year 2010, what is the difference between the Number of procedures in High income: OECD and Number of procedures in Kazakhstan?
Keep it short and to the point. -0.4. In the year 2010, what is the difference between the Number of procedures in Sub-Saharan Africa (developing only) and Number of procedures in Kazakhstan?
Provide a succinct answer. 3.02. In the year 2010, what is the difference between the Number of procedures of Sub-Saharan Africa (developing only) and Number of procedures of Portugal?
Keep it short and to the point. 4.02. What is the ratio of the Number of procedures in High income: OECD in 2003 to that in 2004?
Your answer should be compact. 1.05. What is the ratio of the Number of procedures of Sub-Saharan Africa (developing only) in 2003 to that in 2004?
Your response must be concise. 1.02. What is the ratio of the Number of procedures in Kazakhstan in 2003 to that in 2004?
Provide a short and direct response. 1. What is the ratio of the Number of procedures of High income: OECD in 2003 to that in 2005?
Provide a succinct answer. 1.05. What is the ratio of the Number of procedures of Sub-Saharan Africa (developing only) in 2003 to that in 2005?
Provide a succinct answer. 1.02. What is the ratio of the Number of procedures of Portugal in 2003 to that in 2005?
Keep it short and to the point. 1. What is the ratio of the Number of procedures of High income: OECD in 2003 to that in 2006?
Your response must be concise. 1.09. What is the ratio of the Number of procedures of Sub-Saharan Africa (developing only) in 2003 to that in 2006?
Offer a terse response. 1.04. What is the ratio of the Number of procedures in Portugal in 2003 to that in 2006?
Offer a very short reply. 1.57. What is the ratio of the Number of procedures in High income: OECD in 2003 to that in 2007?
Offer a terse response. 1.1. What is the ratio of the Number of procedures of Sub-Saharan Africa (developing only) in 2003 to that in 2007?
Provide a short and direct response. 1.07. What is the ratio of the Number of procedures of Portugal in 2003 to that in 2007?
Provide a short and direct response. 1.83. What is the ratio of the Number of procedures of High income: OECD in 2003 to that in 2008?
Keep it short and to the point. 1.2. What is the ratio of the Number of procedures in Sub-Saharan Africa (developing only) in 2003 to that in 2008?
Provide a succinct answer. 1.14. What is the ratio of the Number of procedures of Kazakhstan in 2003 to that in 2008?
Provide a succinct answer. 1.25. What is the ratio of the Number of procedures of Portugal in 2003 to that in 2008?
Keep it short and to the point. 2.2. What is the ratio of the Number of procedures in High income: OECD in 2003 to that in 2009?
Keep it short and to the point. 1.25. What is the ratio of the Number of procedures in Sub-Saharan Africa (developing only) in 2003 to that in 2009?
Your answer should be very brief. 1.21. What is the ratio of the Number of procedures of Kazakhstan in 2003 to that in 2009?
Make the answer very short. 1.43. What is the ratio of the Number of procedures of High income: OECD in 2003 to that in 2010?
Your response must be concise. 1.27. What is the ratio of the Number of procedures of Sub-Saharan Africa (developing only) in 2003 to that in 2010?
Give a very brief answer. 1.25. What is the ratio of the Number of procedures of Portugal in 2003 to that in 2010?
Ensure brevity in your answer.  2.2. What is the ratio of the Number of procedures of Sub-Saharan Africa (developing only) in 2004 to that in 2005?
Keep it short and to the point. 1. What is the ratio of the Number of procedures of Kazakhstan in 2004 to that in 2005?
Your response must be concise. 1.25. What is the ratio of the Number of procedures in Portugal in 2004 to that in 2005?
Provide a short and direct response. 1. What is the ratio of the Number of procedures of High income: OECD in 2004 to that in 2006?
Your answer should be compact. 1.04. What is the ratio of the Number of procedures in Sub-Saharan Africa (developing only) in 2004 to that in 2006?
Your response must be concise. 1.02. What is the ratio of the Number of procedures in Portugal in 2004 to that in 2006?
Offer a very short reply. 1.57. What is the ratio of the Number of procedures in High income: OECD in 2004 to that in 2007?
Your answer should be very brief. 1.05. What is the ratio of the Number of procedures of Sub-Saharan Africa (developing only) in 2004 to that in 2007?
Give a very brief answer. 1.05. What is the ratio of the Number of procedures in Kazakhstan in 2004 to that in 2007?
Offer a very short reply. 1.25. What is the ratio of the Number of procedures of Portugal in 2004 to that in 2007?
Offer a very short reply. 1.83. What is the ratio of the Number of procedures of High income: OECD in 2004 to that in 2008?
Your response must be concise. 1.14. What is the ratio of the Number of procedures in Sub-Saharan Africa (developing only) in 2004 to that in 2008?
Ensure brevity in your answer.  1.12. What is the ratio of the Number of procedures of High income: OECD in 2004 to that in 2009?
Offer a very short reply. 1.2. What is the ratio of the Number of procedures of Sub-Saharan Africa (developing only) in 2004 to that in 2009?
Offer a terse response. 1.19. What is the ratio of the Number of procedures in Kazakhstan in 2004 to that in 2009?
Ensure brevity in your answer.  1.43. What is the ratio of the Number of procedures in Portugal in 2004 to that in 2009?
Keep it short and to the point. 2.2. What is the ratio of the Number of procedures in High income: OECD in 2004 to that in 2010?
Keep it short and to the point. 1.21. What is the ratio of the Number of procedures in Sub-Saharan Africa (developing only) in 2004 to that in 2010?
Ensure brevity in your answer.  1.22. What is the ratio of the Number of procedures of Portugal in 2004 to that in 2010?
Provide a succinct answer. 2.2. What is the ratio of the Number of procedures of High income: OECD in 2005 to that in 2006?
Provide a short and direct response. 1.03. What is the ratio of the Number of procedures of Sub-Saharan Africa (developing only) in 2005 to that in 2006?
Give a very brief answer. 1.02. What is the ratio of the Number of procedures in Kazakhstan in 2005 to that in 2006?
Offer a terse response. 1. What is the ratio of the Number of procedures of Portugal in 2005 to that in 2006?
Your answer should be compact. 1.57. What is the ratio of the Number of procedures of High income: OECD in 2005 to that in 2007?
Keep it short and to the point. 1.05. What is the ratio of the Number of procedures of Sub-Saharan Africa (developing only) in 2005 to that in 2007?
Provide a short and direct response. 1.05. What is the ratio of the Number of procedures of Portugal in 2005 to that in 2007?
Keep it short and to the point. 1.83. What is the ratio of the Number of procedures of High income: OECD in 2005 to that in 2008?
Provide a succinct answer. 1.14. What is the ratio of the Number of procedures in Sub-Saharan Africa (developing only) in 2005 to that in 2008?
Ensure brevity in your answer.  1.12. What is the ratio of the Number of procedures of Kazakhstan in 2005 to that in 2008?
Provide a succinct answer. 1. What is the ratio of the Number of procedures of Portugal in 2005 to that in 2008?
Ensure brevity in your answer.  2.2. What is the ratio of the Number of procedures of High income: OECD in 2005 to that in 2009?
Your answer should be compact. 1.19. What is the ratio of the Number of procedures in Sub-Saharan Africa (developing only) in 2005 to that in 2009?
Offer a very short reply. 1.19. What is the ratio of the Number of procedures in Kazakhstan in 2005 to that in 2009?
Provide a short and direct response. 1.14. What is the ratio of the Number of procedures in Portugal in 2005 to that in 2009?
Provide a succinct answer. 2.2. What is the ratio of the Number of procedures in High income: OECD in 2005 to that in 2010?
Provide a short and direct response. 1.21. What is the ratio of the Number of procedures of Sub-Saharan Africa (developing only) in 2005 to that in 2010?
Offer a terse response. 1.22. What is the ratio of the Number of procedures in Kazakhstan in 2005 to that in 2010?
Your response must be concise. 1.33. What is the ratio of the Number of procedures of Portugal in 2005 to that in 2010?
Offer a terse response. 2.2. What is the ratio of the Number of procedures of High income: OECD in 2006 to that in 2007?
Provide a succinct answer. 1.01. What is the ratio of the Number of procedures of Sub-Saharan Africa (developing only) in 2006 to that in 2007?
Your response must be concise. 1.03. What is the ratio of the Number of procedures in Kazakhstan in 2006 to that in 2007?
Give a very brief answer. 1. What is the ratio of the Number of procedures of High income: OECD in 2006 to that in 2008?
Make the answer very short. 1.1. What is the ratio of the Number of procedures of Sub-Saharan Africa (developing only) in 2006 to that in 2008?
Provide a short and direct response. 1.1. What is the ratio of the Number of procedures in Kazakhstan in 2006 to that in 2008?
Offer a terse response. 1. What is the ratio of the Number of procedures in Portugal in 2006 to that in 2008?
Ensure brevity in your answer.  1.4. What is the ratio of the Number of procedures in High income: OECD in 2006 to that in 2009?
Your answer should be compact. 1.15. What is the ratio of the Number of procedures of Sub-Saharan Africa (developing only) in 2006 to that in 2009?
Your answer should be very brief. 1.16. What is the ratio of the Number of procedures in Portugal in 2006 to that in 2009?
Offer a terse response. 1.4. What is the ratio of the Number of procedures in High income: OECD in 2006 to that in 2010?
Your answer should be very brief. 1.17. What is the ratio of the Number of procedures in Sub-Saharan Africa (developing only) in 2006 to that in 2010?
Your response must be concise. 1.2. What is the ratio of the Number of procedures of Kazakhstan in 2006 to that in 2010?
Your answer should be very brief. 1.33. What is the ratio of the Number of procedures of High income: OECD in 2007 to that in 2008?
Your answer should be very brief. 1.09. What is the ratio of the Number of procedures of Sub-Saharan Africa (developing only) in 2007 to that in 2008?
Offer a very short reply. 1.07. What is the ratio of the Number of procedures in Portugal in 2007 to that in 2008?
Ensure brevity in your answer.  1.2. What is the ratio of the Number of procedures of High income: OECD in 2007 to that in 2009?
Provide a succinct answer. 1.14. What is the ratio of the Number of procedures of Sub-Saharan Africa (developing only) in 2007 to that in 2009?
Give a very brief answer. 1.13. What is the ratio of the Number of procedures in Kazakhstan in 2007 to that in 2009?
Offer a terse response. 1.14. What is the ratio of the Number of procedures of Portugal in 2007 to that in 2009?
Give a very brief answer. 1.2. What is the ratio of the Number of procedures of High income: OECD in 2007 to that in 2010?
Your answer should be compact. 1.15. What is the ratio of the Number of procedures in Sub-Saharan Africa (developing only) in 2007 to that in 2010?
Offer a terse response. 1.16. What is the ratio of the Number of procedures in Kazakhstan in 2007 to that in 2010?
Provide a succinct answer. 1.33. What is the ratio of the Number of procedures in High income: OECD in 2008 to that in 2009?
Offer a terse response. 1.05. What is the ratio of the Number of procedures of Sub-Saharan Africa (developing only) in 2008 to that in 2009?
Ensure brevity in your answer.  1.06. What is the ratio of the Number of procedures in Kazakhstan in 2008 to that in 2009?
Your response must be concise. 1.14. What is the ratio of the Number of procedures of Portugal in 2008 to that in 2009?
Offer a terse response. 1. What is the ratio of the Number of procedures of High income: OECD in 2008 to that in 2010?
Your answer should be very brief. 1.06. What is the ratio of the Number of procedures of Sub-Saharan Africa (developing only) in 2008 to that in 2010?
Give a very brief answer. 1.09. What is the ratio of the Number of procedures in Portugal in 2008 to that in 2010?
Ensure brevity in your answer.  1. What is the ratio of the Number of procedures of High income: OECD in 2009 to that in 2010?
Ensure brevity in your answer.  1.01. What is the ratio of the Number of procedures in Sub-Saharan Africa (developing only) in 2009 to that in 2010?
Give a very brief answer. 1.03. What is the ratio of the Number of procedures in Kazakhstan in 2009 to that in 2010?
Keep it short and to the point. 1.17. What is the ratio of the Number of procedures in Portugal in 2009 to that in 2010?
Provide a succinct answer. 1. What is the difference between the highest and the second highest Number of procedures in High income: OECD?
Offer a terse response. 0.31. What is the difference between the highest and the second highest Number of procedures in Sub-Saharan Africa (developing only)?
Give a very brief answer. 0.22. What is the difference between the highest and the second highest Number of procedures of Kazakhstan?
Your answer should be compact. 0. What is the difference between the highest and the second highest Number of procedures in Portugal?
Give a very brief answer. 0. What is the difference between the highest and the lowest Number of procedures of High income: OECD?
Your response must be concise. 1.51. What is the difference between the highest and the lowest Number of procedures of Sub-Saharan Africa (developing only)?
Your response must be concise. 2.23. What is the difference between the highest and the lowest Number of procedures in Kazakhstan?
Your answer should be compact. 4. What is the difference between the highest and the lowest Number of procedures in Portugal?
Make the answer very short. 6. 